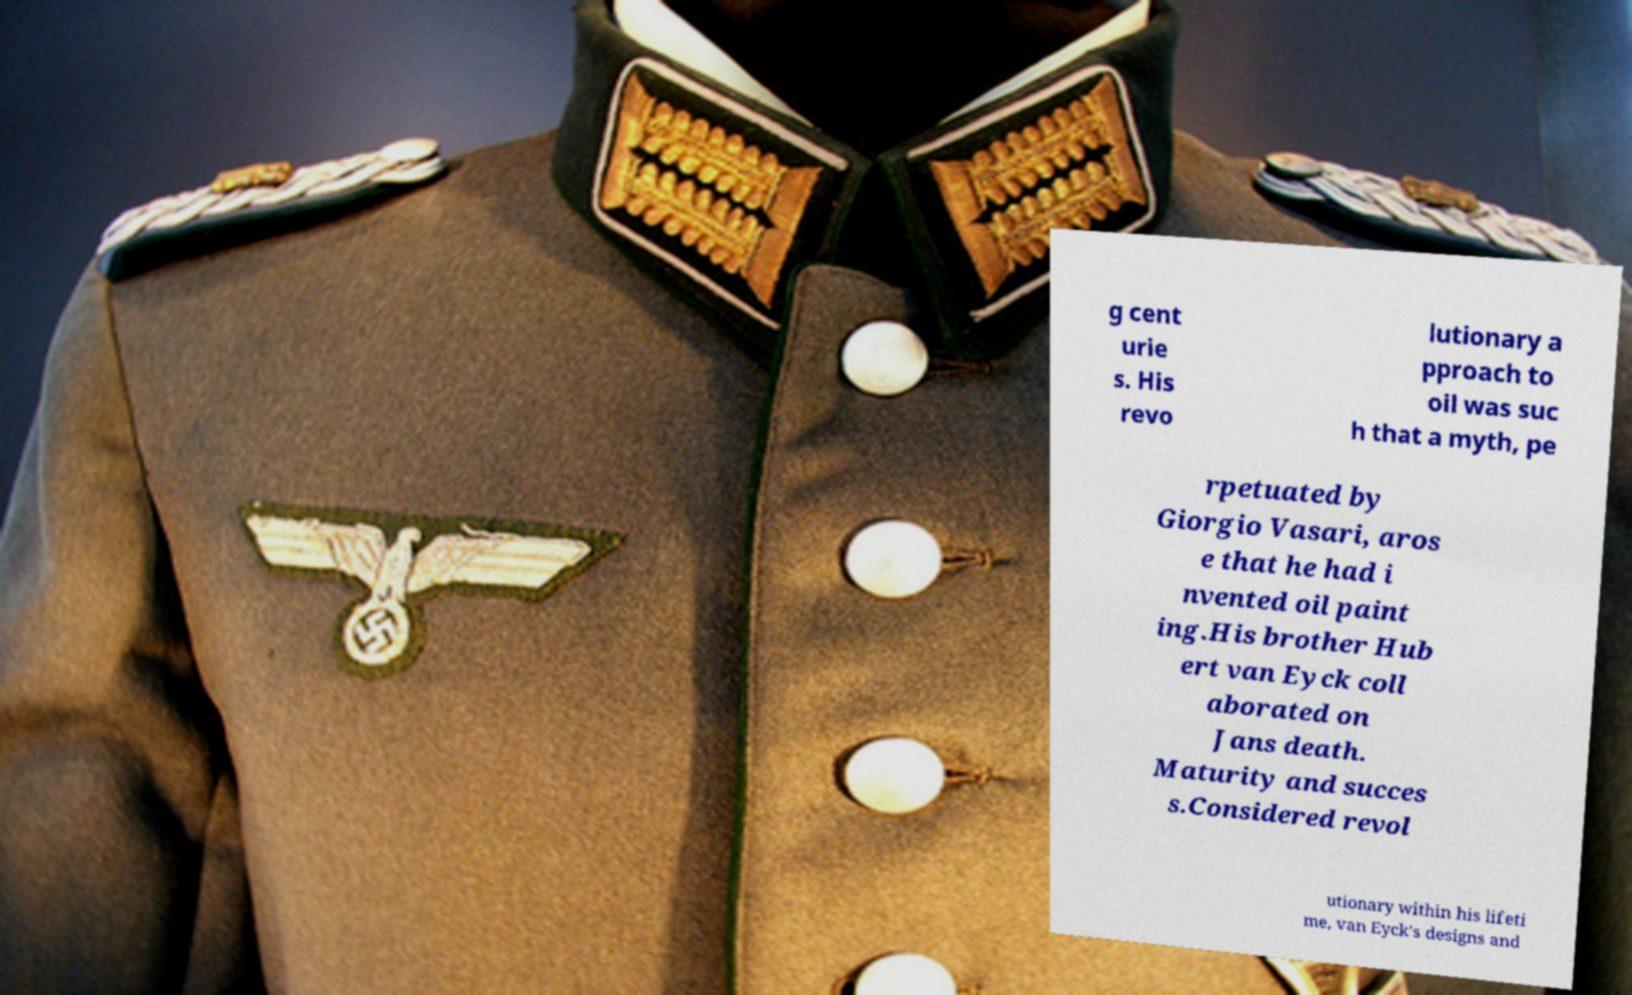Can you accurately transcribe the text from the provided image for me? g cent urie s. His revo lutionary a pproach to oil was suc h that a myth, pe rpetuated by Giorgio Vasari, aros e that he had i nvented oil paint ing.His brother Hub ert van Eyck coll aborated on Jans death. Maturity and succes s.Considered revol utionary within his lifeti me, van Eyck's designs and 